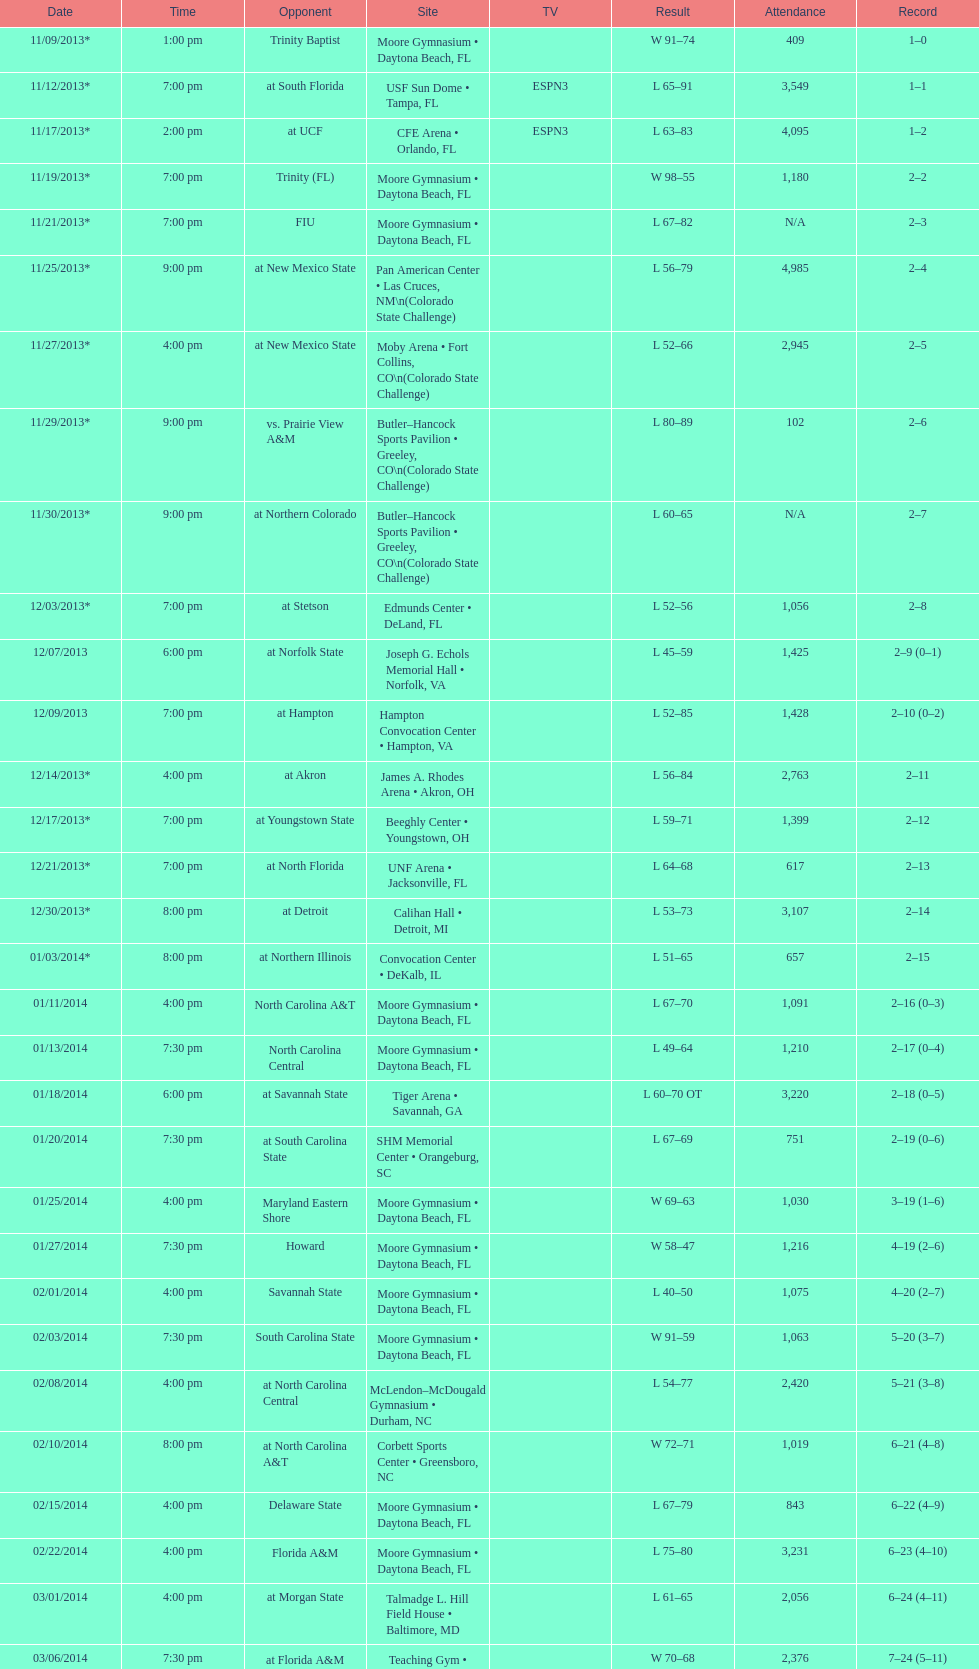Can you give me this table as a dict? {'header': ['Date', 'Time', 'Opponent', 'Site', 'TV', 'Result', 'Attendance', 'Record'], 'rows': [['11/09/2013*', '1:00 pm', 'Trinity Baptist', 'Moore Gymnasium • Daytona Beach, FL', '', 'W\xa091–74', '409', '1–0'], ['11/12/2013*', '7:00 pm', 'at\xa0South Florida', 'USF Sun Dome • Tampa, FL', 'ESPN3', 'L\xa065–91', '3,549', '1–1'], ['11/17/2013*', '2:00 pm', 'at\xa0UCF', 'CFE Arena • Orlando, FL', 'ESPN3', 'L\xa063–83', '4,095', '1–2'], ['11/19/2013*', '7:00 pm', 'Trinity (FL)', 'Moore Gymnasium • Daytona Beach, FL', '', 'W\xa098–55', '1,180', '2–2'], ['11/21/2013*', '7:00 pm', 'FIU', 'Moore Gymnasium • Daytona Beach, FL', '', 'L\xa067–82', 'N/A', '2–3'], ['11/25/2013*', '9:00 pm', 'at\xa0New Mexico State', 'Pan American Center • Las Cruces, NM\\n(Colorado State Challenge)', '', 'L\xa056–79', '4,985', '2–4'], ['11/27/2013*', '4:00 pm', 'at\xa0New Mexico State', 'Moby Arena • Fort Collins, CO\\n(Colorado State Challenge)', '', 'L\xa052–66', '2,945', '2–5'], ['11/29/2013*', '9:00 pm', 'vs.\xa0Prairie View A&M', 'Butler–Hancock Sports Pavilion • Greeley, CO\\n(Colorado State Challenge)', '', 'L\xa080–89', '102', '2–6'], ['11/30/2013*', '9:00 pm', 'at\xa0Northern Colorado', 'Butler–Hancock Sports Pavilion • Greeley, CO\\n(Colorado State Challenge)', '', 'L\xa060–65', 'N/A', '2–7'], ['12/03/2013*', '7:00 pm', 'at\xa0Stetson', 'Edmunds Center • DeLand, FL', '', 'L\xa052–56', '1,056', '2–8'], ['12/07/2013', '6:00 pm', 'at\xa0Norfolk State', 'Joseph G. Echols Memorial Hall • Norfolk, VA', '', 'L\xa045–59', '1,425', '2–9 (0–1)'], ['12/09/2013', '7:00 pm', 'at\xa0Hampton', 'Hampton Convocation Center • Hampton, VA', '', 'L\xa052–85', '1,428', '2–10 (0–2)'], ['12/14/2013*', '4:00 pm', 'at\xa0Akron', 'James A. Rhodes Arena • Akron, OH', '', 'L\xa056–84', '2,763', '2–11'], ['12/17/2013*', '7:00 pm', 'at\xa0Youngstown State', 'Beeghly Center • Youngstown, OH', '', 'L\xa059–71', '1,399', '2–12'], ['12/21/2013*', '7:00 pm', 'at\xa0North Florida', 'UNF Arena • Jacksonville, FL', '', 'L\xa064–68', '617', '2–13'], ['12/30/2013*', '8:00 pm', 'at\xa0Detroit', 'Calihan Hall • Detroit, MI', '', 'L\xa053–73', '3,107', '2–14'], ['01/03/2014*', '8:00 pm', 'at\xa0Northern Illinois', 'Convocation Center • DeKalb, IL', '', 'L\xa051–65', '657', '2–15'], ['01/11/2014', '4:00 pm', 'North Carolina A&T', 'Moore Gymnasium • Daytona Beach, FL', '', 'L\xa067–70', '1,091', '2–16 (0–3)'], ['01/13/2014', '7:30 pm', 'North Carolina Central', 'Moore Gymnasium • Daytona Beach, FL', '', 'L\xa049–64', '1,210', '2–17 (0–4)'], ['01/18/2014', '6:00 pm', 'at\xa0Savannah State', 'Tiger Arena • Savannah, GA', '', 'L\xa060–70\xa0OT', '3,220', '2–18 (0–5)'], ['01/20/2014', '7:30 pm', 'at\xa0South Carolina State', 'SHM Memorial Center • Orangeburg, SC', '', 'L\xa067–69', '751', '2–19 (0–6)'], ['01/25/2014', '4:00 pm', 'Maryland Eastern Shore', 'Moore Gymnasium • Daytona Beach, FL', '', 'W\xa069–63', '1,030', '3–19 (1–6)'], ['01/27/2014', '7:30 pm', 'Howard', 'Moore Gymnasium • Daytona Beach, FL', '', 'W\xa058–47', '1,216', '4–19 (2–6)'], ['02/01/2014', '4:00 pm', 'Savannah State', 'Moore Gymnasium • Daytona Beach, FL', '', 'L\xa040–50', '1,075', '4–20 (2–7)'], ['02/03/2014', '7:30 pm', 'South Carolina State', 'Moore Gymnasium • Daytona Beach, FL', '', 'W\xa091–59', '1,063', '5–20 (3–7)'], ['02/08/2014', '4:00 pm', 'at\xa0North Carolina Central', 'McLendon–McDougald Gymnasium • Durham, NC', '', 'L\xa054–77', '2,420', '5–21 (3–8)'], ['02/10/2014', '8:00 pm', 'at\xa0North Carolina A&T', 'Corbett Sports Center • Greensboro, NC', '', 'W\xa072–71', '1,019', '6–21 (4–8)'], ['02/15/2014', '4:00 pm', 'Delaware State', 'Moore Gymnasium • Daytona Beach, FL', '', 'L\xa067–79', '843', '6–22 (4–9)'], ['02/22/2014', '4:00 pm', 'Florida A&M', 'Moore Gymnasium • Daytona Beach, FL', '', 'L\xa075–80', '3,231', '6–23 (4–10)'], ['03/01/2014', '4:00 pm', 'at\xa0Morgan State', 'Talmadge L. Hill Field House • Baltimore, MD', '', 'L\xa061–65', '2,056', '6–24 (4–11)'], ['03/06/2014', '7:30 pm', 'at\xa0Florida A&M', 'Teaching Gym • Tallahassee, FL', '', 'W\xa070–68', '2,376', '7–24 (5–11)'], ['03/11/2014', '6:30 pm', 'vs.\xa0Coppin State', 'Norfolk Scope • Norfolk, VA\\n(First round)', '', 'L\xa068–75', '4,658', '7–25']]} Which game occurred later in the evening, fiu or northern colorado? Northern Colorado. 